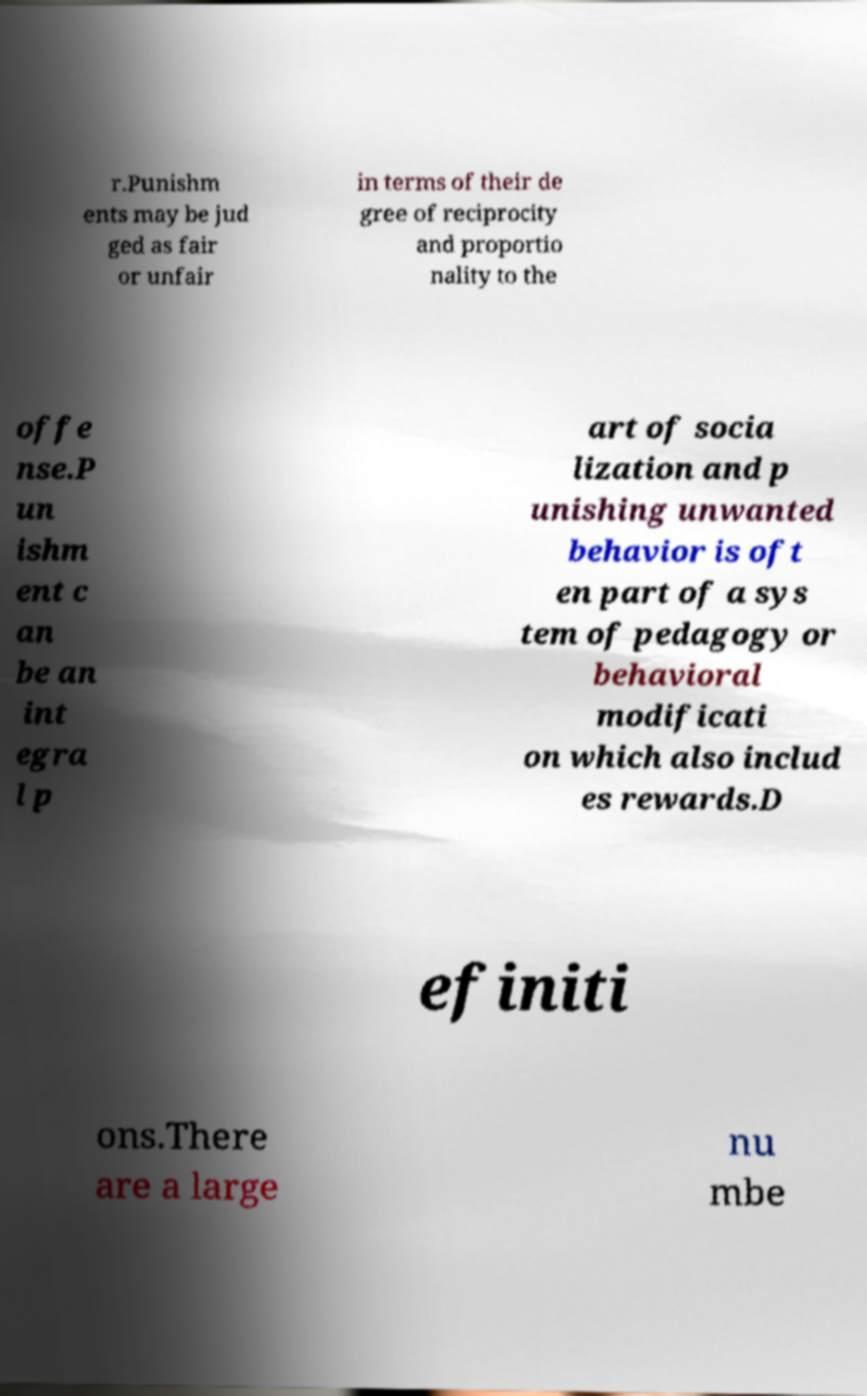Could you assist in decoding the text presented in this image and type it out clearly? r.Punishm ents may be jud ged as fair or unfair in terms of their de gree of reciprocity and proportio nality to the offe nse.P un ishm ent c an be an int egra l p art of socia lization and p unishing unwanted behavior is oft en part of a sys tem of pedagogy or behavioral modificati on which also includ es rewards.D efiniti ons.There are a large nu mbe 